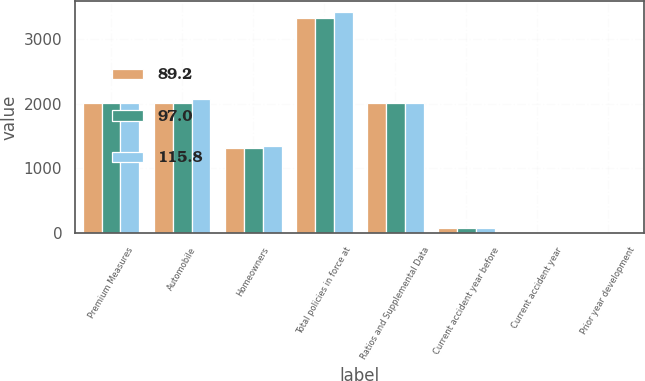<chart> <loc_0><loc_0><loc_500><loc_500><stacked_bar_chart><ecel><fcel>Premium Measures<fcel>Automobile<fcel>Homeowners<fcel>Total policies in force at<fcel>Ratios and Supplemental Data<fcel>Current accident year before<fcel>Current accident year<fcel>Prior year development<nl><fcel>89.2<fcel>2013<fcel>2019<fcel>1319<fcel>3338<fcel>2013<fcel>65.9<fcel>5.7<fcel>1.1<nl><fcel>97<fcel>2012<fcel>2015<fcel>1319<fcel>3334<fcel>2012<fcel>65.7<fcel>10.5<fcel>3.9<nl><fcel>115.8<fcel>2011<fcel>2081<fcel>1339<fcel>3419<fcel>2011<fcel>67.7<fcel>11.3<fcel>2<nl></chart> 